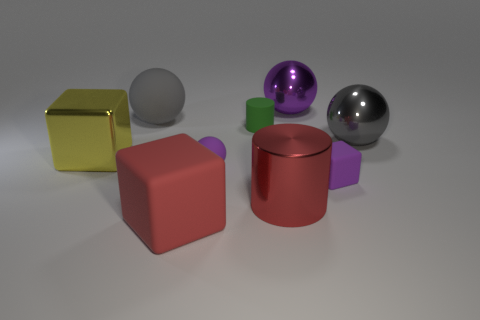Subtract all blocks. How many objects are left? 6 Add 9 tiny green matte things. How many tiny green matte things are left? 10 Add 3 matte balls. How many matte balls exist? 5 Subtract 1 red cubes. How many objects are left? 8 Subtract all yellow spheres. Subtract all purple blocks. How many objects are left? 8 